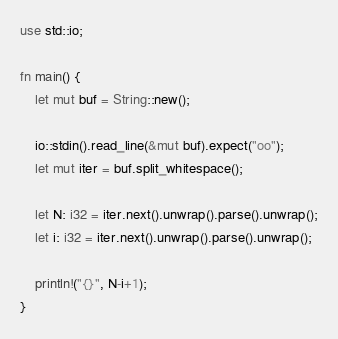Convert code to text. <code><loc_0><loc_0><loc_500><loc_500><_Rust_>use std::io;

fn main() {
    let mut buf = String::new();

    io::stdin().read_line(&mut buf).expect("oo");
    let mut iter = buf.split_whitespace();

    let N: i32 = iter.next().unwrap().parse().unwrap();
    let i: i32 = iter.next().unwrap().parse().unwrap();

    println!("{}", N-i+1);
}
</code> 